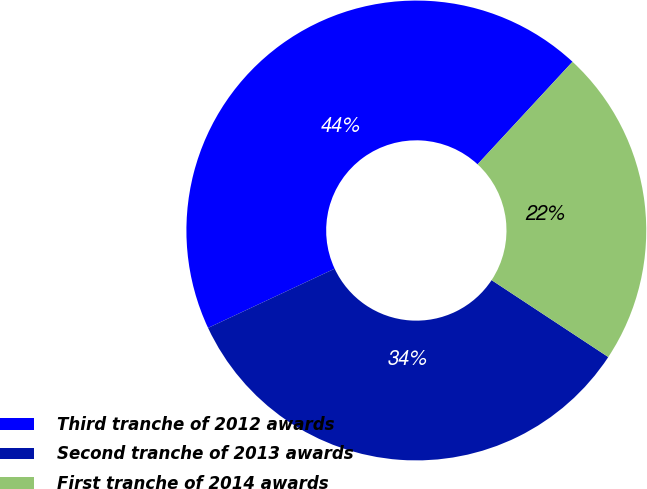Convert chart. <chart><loc_0><loc_0><loc_500><loc_500><pie_chart><fcel>Third tranche of 2012 awards<fcel>Second tranche of 2013 awards<fcel>First tranche of 2014 awards<nl><fcel>43.85%<fcel>33.76%<fcel>22.39%<nl></chart> 